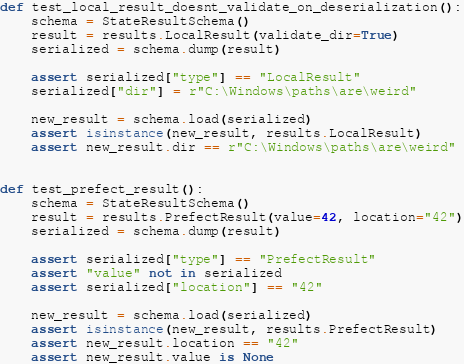Convert code to text. <code><loc_0><loc_0><loc_500><loc_500><_Python_>def test_local_result_doesnt_validate_on_deserialization():
    schema = StateResultSchema()
    result = results.LocalResult(validate_dir=True)
    serialized = schema.dump(result)

    assert serialized["type"] == "LocalResult"
    serialized["dir"] = r"C:\Windows\paths\are\weird"

    new_result = schema.load(serialized)
    assert isinstance(new_result, results.LocalResult)
    assert new_result.dir == r"C:\Windows\paths\are\weird"


def test_prefect_result():
    schema = StateResultSchema()
    result = results.PrefectResult(value=42, location="42")
    serialized = schema.dump(result)

    assert serialized["type"] == "PrefectResult"
    assert "value" not in serialized
    assert serialized["location"] == "42"

    new_result = schema.load(serialized)
    assert isinstance(new_result, results.PrefectResult)
    assert new_result.location == "42"
    assert new_result.value is None

</code> 